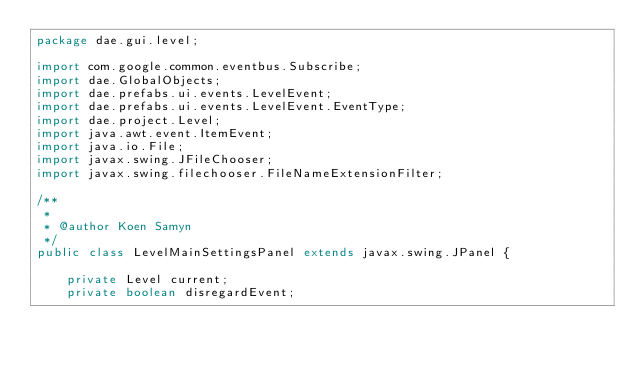Convert code to text. <code><loc_0><loc_0><loc_500><loc_500><_Java_>package dae.gui.level;

import com.google.common.eventbus.Subscribe;
import dae.GlobalObjects;
import dae.prefabs.ui.events.LevelEvent;
import dae.prefabs.ui.events.LevelEvent.EventType;
import dae.project.Level;
import java.awt.event.ItemEvent;
import java.io.File;
import javax.swing.JFileChooser;
import javax.swing.filechooser.FileNameExtensionFilter;

/**
 *
 * @author Koen Samyn
 */
public class LevelMainSettingsPanel extends javax.swing.JPanel {

    private Level current;
    private boolean disregardEvent;
</code> 